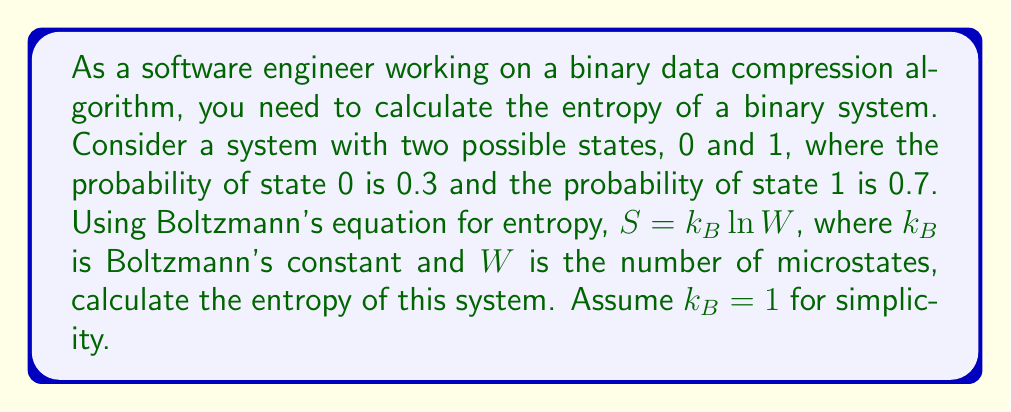Can you solve this math problem? To calculate the entropy of this binary system using Boltzmann's equation, we need to follow these steps:

1. Understand the given information:
   - We have a binary system with two states: 0 and 1
   - Probability of state 0: $p_0 = 0.3$
   - Probability of state 1: $p_1 = 0.7$
   - Boltzmann's equation: $S = k_B \ln W$
   - $k_B = 1$ (assumed for simplicity)

2. For a binary system, we need to use the Shannon entropy formula, which is derived from Boltzmann's equation:
   $$S = -k_B \sum_i p_i \ln p_i$$

3. Substitute the probabilities into the formula:
   $$S = -k_B (p_0 \ln p_0 + p_1 \ln p_1)$$

4. Insert the given probability values:
   $$S = -(0.3 \ln 0.3 + 0.7 \ln 0.7)$$

5. Calculate the natural logarithms:
   $$S = -(0.3 \times (-1.2040) + 0.7 \times (-0.3567))$$

6. Multiply:
   $$S = -((-0.3612) + (-0.2497))$$

7. Simplify:
   $$S = 0.6109$$

The entropy of the binary system is approximately 0.6109.
Answer: $S = 0.6109$ 